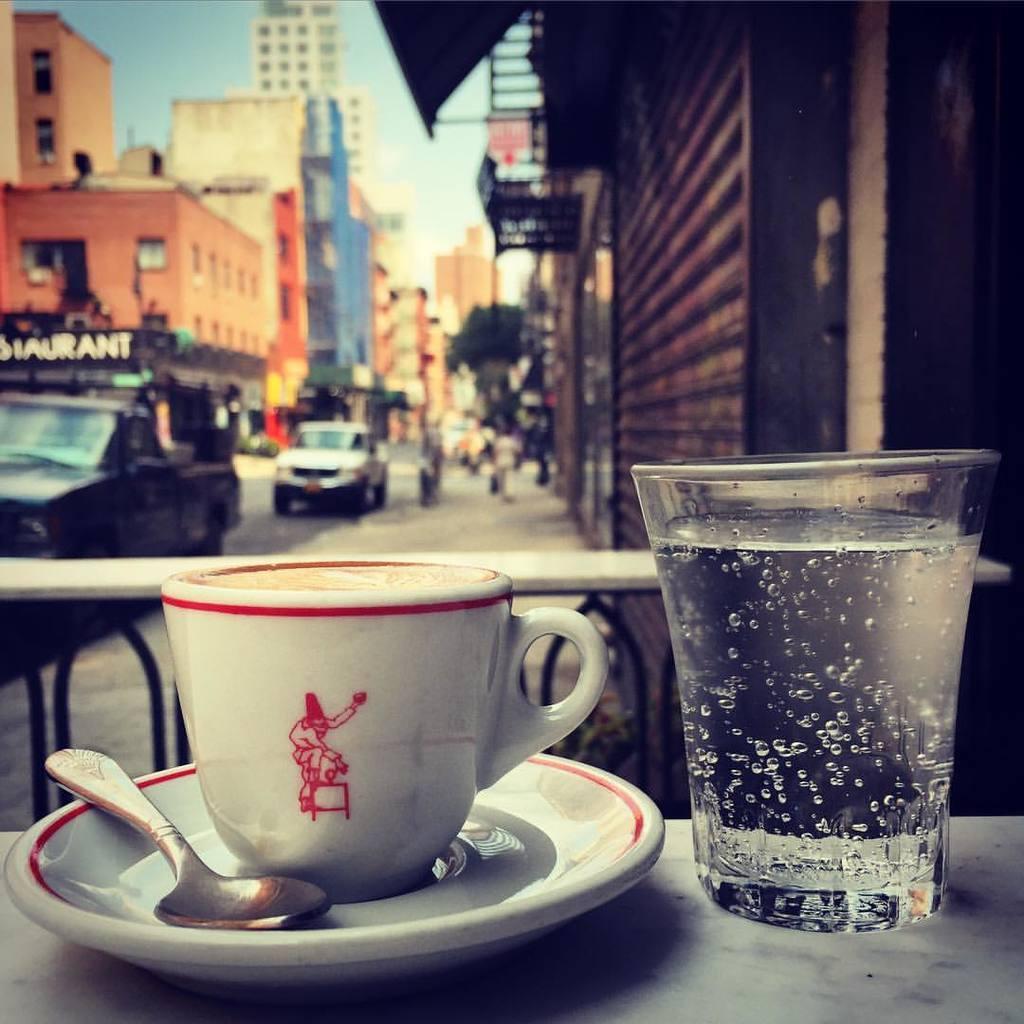In one or two sentences, can you explain what this image depicts? In this image we can see the cup and saucer, spoon and glass which are kept on the surface. And in the background, we can see the vehicles, buildings, and the sky. 